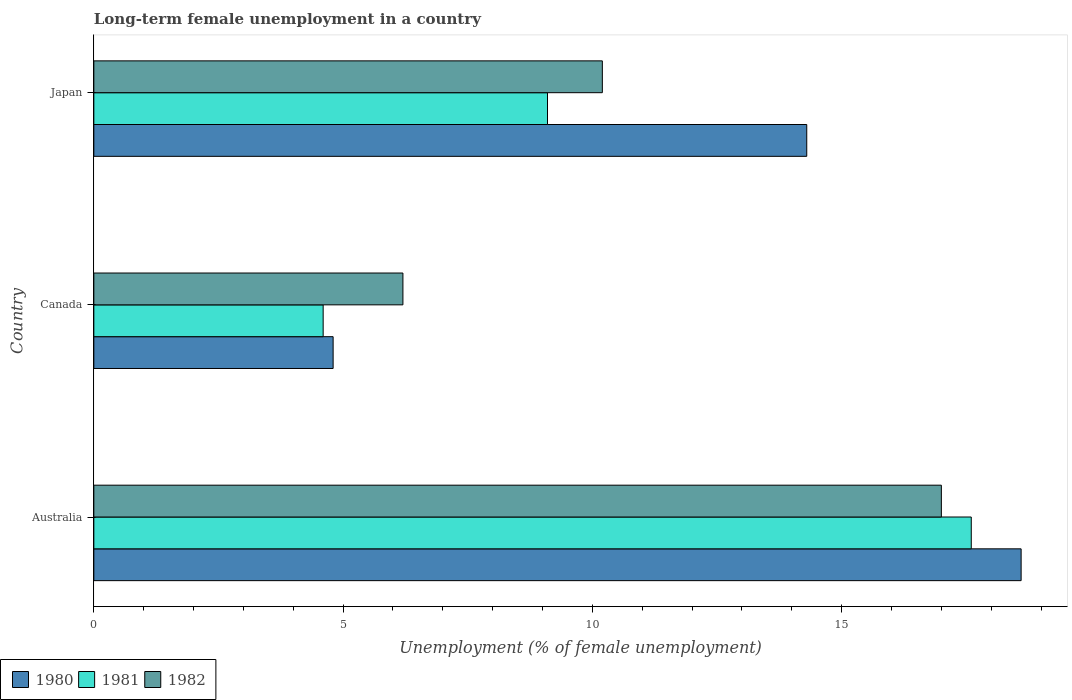How many groups of bars are there?
Keep it short and to the point. 3. How many bars are there on the 1st tick from the bottom?
Make the answer very short. 3. What is the percentage of long-term unemployed female population in 1981 in Australia?
Your answer should be very brief. 17.6. Across all countries, what is the maximum percentage of long-term unemployed female population in 1981?
Ensure brevity in your answer.  17.6. Across all countries, what is the minimum percentage of long-term unemployed female population in 1982?
Offer a very short reply. 6.2. In which country was the percentage of long-term unemployed female population in 1982 maximum?
Your answer should be very brief. Australia. In which country was the percentage of long-term unemployed female population in 1981 minimum?
Offer a terse response. Canada. What is the total percentage of long-term unemployed female population in 1980 in the graph?
Your answer should be very brief. 37.7. What is the difference between the percentage of long-term unemployed female population in 1982 in Australia and that in Japan?
Make the answer very short. 6.8. What is the difference between the percentage of long-term unemployed female population in 1981 in Japan and the percentage of long-term unemployed female population in 1982 in Australia?
Make the answer very short. -7.9. What is the average percentage of long-term unemployed female population in 1981 per country?
Make the answer very short. 10.43. What is the difference between the percentage of long-term unemployed female population in 1982 and percentage of long-term unemployed female population in 1981 in Canada?
Your answer should be very brief. 1.6. In how many countries, is the percentage of long-term unemployed female population in 1981 greater than 5 %?
Provide a succinct answer. 2. What is the ratio of the percentage of long-term unemployed female population in 1982 in Australia to that in Japan?
Offer a terse response. 1.67. Is the percentage of long-term unemployed female population in 1981 in Canada less than that in Japan?
Offer a terse response. Yes. What is the difference between the highest and the second highest percentage of long-term unemployed female population in 1981?
Make the answer very short. 8.5. What is the difference between the highest and the lowest percentage of long-term unemployed female population in 1982?
Ensure brevity in your answer.  10.8. Is the sum of the percentage of long-term unemployed female population in 1982 in Australia and Japan greater than the maximum percentage of long-term unemployed female population in 1981 across all countries?
Provide a succinct answer. Yes. What does the 3rd bar from the top in Australia represents?
Your answer should be compact. 1980. What does the 3rd bar from the bottom in Canada represents?
Make the answer very short. 1982. Are all the bars in the graph horizontal?
Your response must be concise. Yes. How many countries are there in the graph?
Your answer should be very brief. 3. Does the graph contain any zero values?
Your answer should be compact. No. How many legend labels are there?
Offer a very short reply. 3. What is the title of the graph?
Provide a succinct answer. Long-term female unemployment in a country. What is the label or title of the X-axis?
Your response must be concise. Unemployment (% of female unemployment). What is the Unemployment (% of female unemployment) of 1980 in Australia?
Make the answer very short. 18.6. What is the Unemployment (% of female unemployment) in 1981 in Australia?
Your answer should be very brief. 17.6. What is the Unemployment (% of female unemployment) in 1980 in Canada?
Keep it short and to the point. 4.8. What is the Unemployment (% of female unemployment) of 1981 in Canada?
Your answer should be very brief. 4.6. What is the Unemployment (% of female unemployment) in 1982 in Canada?
Your answer should be very brief. 6.2. What is the Unemployment (% of female unemployment) of 1980 in Japan?
Offer a very short reply. 14.3. What is the Unemployment (% of female unemployment) in 1981 in Japan?
Ensure brevity in your answer.  9.1. What is the Unemployment (% of female unemployment) of 1982 in Japan?
Provide a short and direct response. 10.2. Across all countries, what is the maximum Unemployment (% of female unemployment) of 1980?
Give a very brief answer. 18.6. Across all countries, what is the maximum Unemployment (% of female unemployment) of 1981?
Provide a succinct answer. 17.6. Across all countries, what is the minimum Unemployment (% of female unemployment) of 1980?
Your answer should be very brief. 4.8. Across all countries, what is the minimum Unemployment (% of female unemployment) in 1981?
Your answer should be compact. 4.6. Across all countries, what is the minimum Unemployment (% of female unemployment) of 1982?
Give a very brief answer. 6.2. What is the total Unemployment (% of female unemployment) of 1980 in the graph?
Offer a terse response. 37.7. What is the total Unemployment (% of female unemployment) in 1981 in the graph?
Your answer should be compact. 31.3. What is the total Unemployment (% of female unemployment) of 1982 in the graph?
Keep it short and to the point. 33.4. What is the difference between the Unemployment (% of female unemployment) of 1981 in Australia and that in Canada?
Provide a short and direct response. 13. What is the difference between the Unemployment (% of female unemployment) of 1981 in Australia and that in Japan?
Provide a short and direct response. 8.5. What is the difference between the Unemployment (% of female unemployment) of 1982 in Australia and that in Japan?
Your answer should be very brief. 6.8. What is the difference between the Unemployment (% of female unemployment) in 1980 in Canada and that in Japan?
Your answer should be compact. -9.5. What is the difference between the Unemployment (% of female unemployment) in 1981 in Australia and the Unemployment (% of female unemployment) in 1982 in Canada?
Provide a short and direct response. 11.4. What is the difference between the Unemployment (% of female unemployment) in 1980 in Australia and the Unemployment (% of female unemployment) in 1981 in Japan?
Offer a terse response. 9.5. What is the difference between the Unemployment (% of female unemployment) of 1981 in Australia and the Unemployment (% of female unemployment) of 1982 in Japan?
Your response must be concise. 7.4. What is the difference between the Unemployment (% of female unemployment) of 1980 in Canada and the Unemployment (% of female unemployment) of 1981 in Japan?
Provide a succinct answer. -4.3. What is the difference between the Unemployment (% of female unemployment) of 1981 in Canada and the Unemployment (% of female unemployment) of 1982 in Japan?
Your answer should be very brief. -5.6. What is the average Unemployment (% of female unemployment) in 1980 per country?
Give a very brief answer. 12.57. What is the average Unemployment (% of female unemployment) in 1981 per country?
Offer a terse response. 10.43. What is the average Unemployment (% of female unemployment) of 1982 per country?
Your answer should be compact. 11.13. What is the difference between the Unemployment (% of female unemployment) in 1980 and Unemployment (% of female unemployment) in 1982 in Australia?
Your answer should be compact. 1.6. What is the difference between the Unemployment (% of female unemployment) of 1980 and Unemployment (% of female unemployment) of 1981 in Japan?
Keep it short and to the point. 5.2. What is the ratio of the Unemployment (% of female unemployment) of 1980 in Australia to that in Canada?
Ensure brevity in your answer.  3.88. What is the ratio of the Unemployment (% of female unemployment) in 1981 in Australia to that in Canada?
Provide a short and direct response. 3.83. What is the ratio of the Unemployment (% of female unemployment) in 1982 in Australia to that in Canada?
Provide a succinct answer. 2.74. What is the ratio of the Unemployment (% of female unemployment) in 1980 in Australia to that in Japan?
Your answer should be very brief. 1.3. What is the ratio of the Unemployment (% of female unemployment) of 1981 in Australia to that in Japan?
Offer a terse response. 1.93. What is the ratio of the Unemployment (% of female unemployment) of 1980 in Canada to that in Japan?
Provide a short and direct response. 0.34. What is the ratio of the Unemployment (% of female unemployment) in 1981 in Canada to that in Japan?
Keep it short and to the point. 0.51. What is the ratio of the Unemployment (% of female unemployment) of 1982 in Canada to that in Japan?
Provide a short and direct response. 0.61. What is the difference between the highest and the second highest Unemployment (% of female unemployment) of 1980?
Offer a very short reply. 4.3. What is the difference between the highest and the second highest Unemployment (% of female unemployment) in 1981?
Your answer should be very brief. 8.5. 